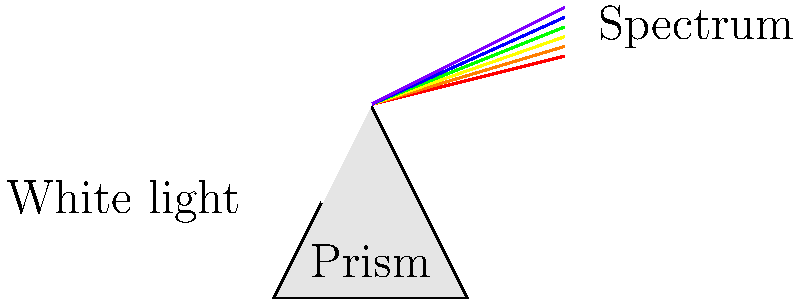In the diagram above, white light passes through a prism and separates into a spectrum of colors. This phenomenon demonstrates the principle of dispersion. Which color of light experiences the least refraction (bends the least) when passing through the prism? To answer this question, we need to understand the relationship between the wavelength of light and its refraction:

1. White light is composed of all visible wavelengths of light.
2. When light enters a prism, it slows down and changes direction (refracts).
3. The amount of refraction depends on the wavelength of the light.
4. Shorter wavelengths (like blue and violet) slow down more and refract more.
5. Longer wavelengths (like red and orange) slow down less and refract less.
6. The colors of the visible spectrum, from longest to shortest wavelength, are: red, orange, yellow, green, blue, violet.
7. In the diagram, we can see that red light is at the bottom of the spectrum, indicating it has bent the least.

Therefore, red light, which has the longest wavelength in the visible spectrum, experiences the least refraction when passing through the prism.
Answer: Red light 